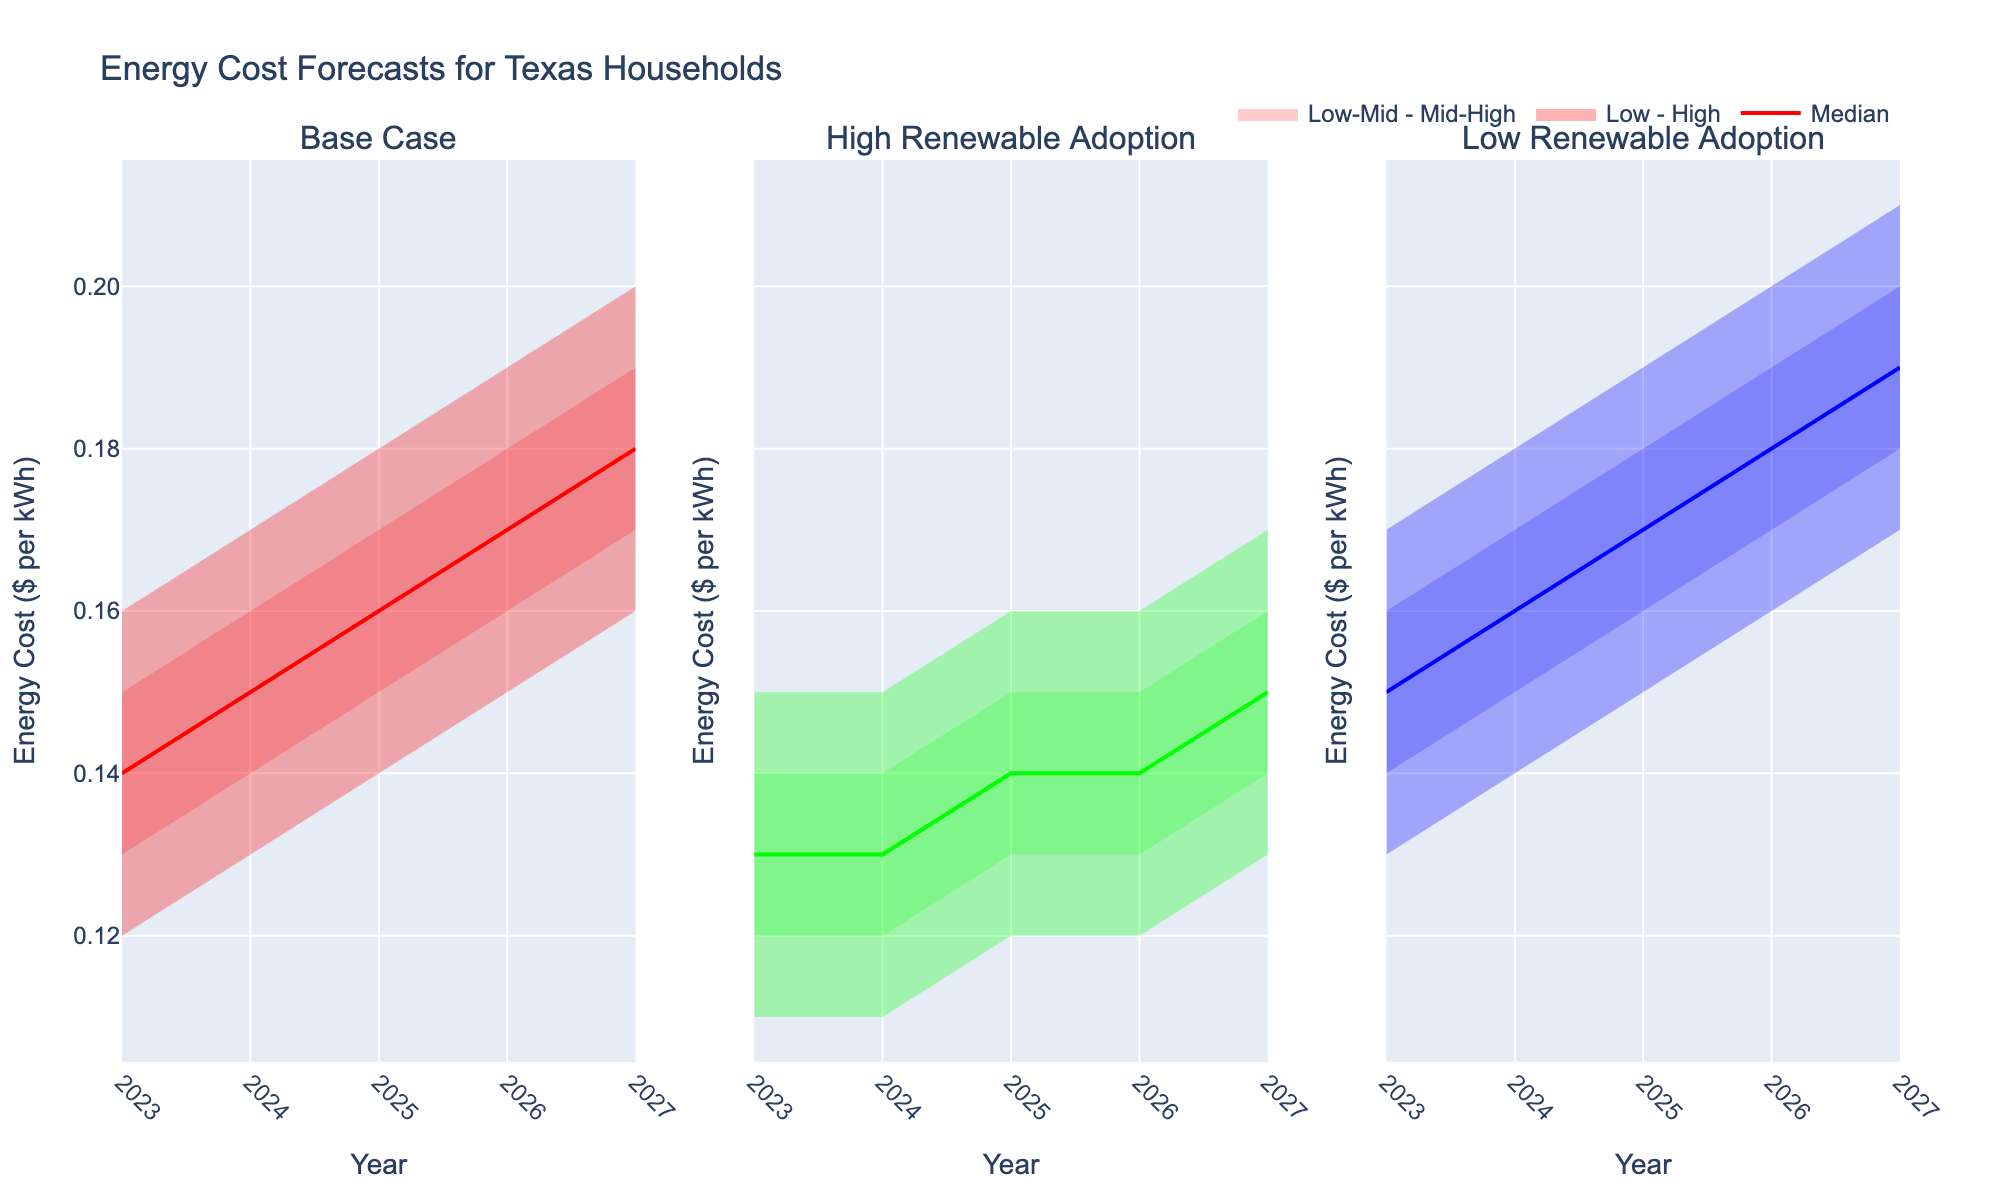What's the title of the chart? The title is usually located at the top of the chart. In this case, it would be displayed clearly based on the given code.
Answer: Energy Cost Forecasts for Texas Households How many scenarios are compared in the chart? The number of scenarios is determined by the subplot titles, which are 'Base Case', 'High Renewable Adoption', and 'Low Renewable Adoption'. This is evident from the unique scenarios in the data.
Answer: Three What is the median energy cost in the Base Case scenario in 2025? The median energy cost for the Base Case scenario in 2025 can be found in the 'Mid' column for that year and scenario.
Answer: 0.16 How does the energy cost change from 2023 to 2027 in the High Renewable Adoption scenario? To see the change, look at the median costs ('Mid' column) for 2023 and 2027 in the High Renewable Adoption scenario. The costs increase from 0.13 to 0.15.
Answer: It increases by 0.02 What's the difference between the highest and lowest energy costs in the Low Renewable Adoption scenario in 2027? The highest and lowest energy costs are given by the 'High' and 'Low' columns respectively for 2027. The difference is 0.21 - 0.17.
Answer: 0.04 Which scenario has the highest median energy cost in 2024? Compare the median values ('Mid' column) for each scenario in 2024. Low Renewable Adoption has the highest median value of 0.16 compared to Base Case and High Renewable Adoption.
Answer: Low Renewable Adoption In 2026, which scenario has the widest range of energy costs? To determine the widest range, subtract the 'Low' value from the 'High' value for each scenario in 2026. The widest difference is in the Low Renewable Adoption scenario (0.20 - 0.16 = 0.04).
Answer: Low Renewable Adoption What is the trend in energy costs over the years for the Base Case scenario? Observing the 'Mid' column values from 2023 to 2027, the energy costs show an increasing trend from 0.14 to 0.18.
Answer: Increasing In which year do Base Case scenario and High Renewable Adoption scenario have the same median energy cost? By looking at the 'Mid' column values across both scenarios, 2026 is the year where both have a median energy cost of 0.17.
Answer: 2026 If energy costs in the Base Case scenario are always $0.01 higher each year, does the observed data follow this pattern? Checking the 'Mid' column for the Base Case scenario, the cost increases from 0.14 in 2023 to 0.15 in 2024, and follows an annual increase of $0.01.
Answer: Yes 